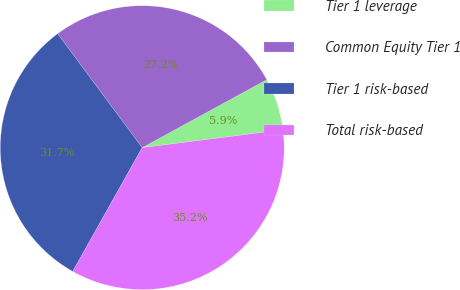Convert chart to OTSL. <chart><loc_0><loc_0><loc_500><loc_500><pie_chart><fcel>Tier 1 leverage<fcel>Common Equity Tier 1<fcel>Tier 1 risk-based<fcel>Total risk-based<nl><fcel>5.94%<fcel>27.21%<fcel>31.7%<fcel>35.15%<nl></chart> 